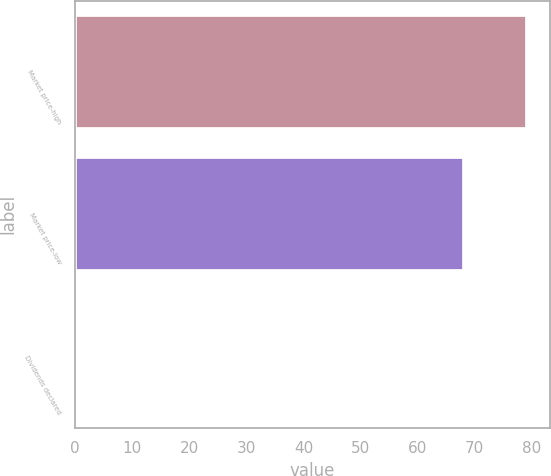<chart> <loc_0><loc_0><loc_500><loc_500><bar_chart><fcel>Market price-high<fcel>Market price-low<fcel>Dividends declared<nl><fcel>79.16<fcel>68.18<fcel>0.57<nl></chart> 